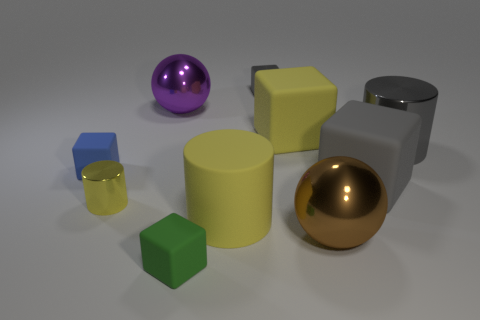Subtract all yellow blocks. How many blocks are left? 4 Subtract all large gray matte cubes. How many cubes are left? 4 Subtract 2 cubes. How many cubes are left? 3 Subtract all cyan cubes. Subtract all green spheres. How many cubes are left? 5 Subtract all balls. How many objects are left? 8 Subtract 0 gray spheres. How many objects are left? 10 Subtract all big brown things. Subtract all tiny green rubber objects. How many objects are left? 8 Add 6 big purple balls. How many big purple balls are left? 7 Add 2 tiny metal blocks. How many tiny metal blocks exist? 3 